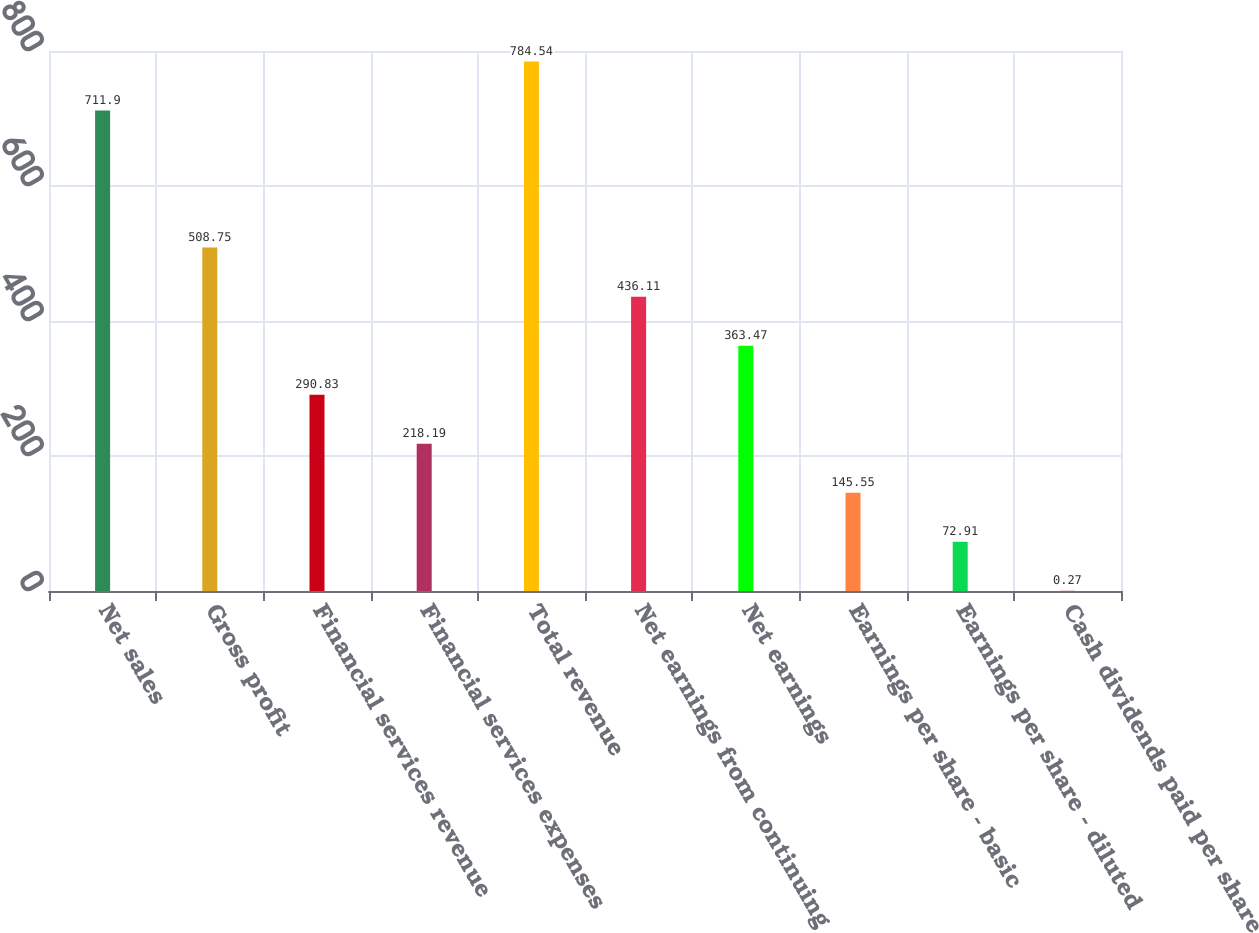Convert chart. <chart><loc_0><loc_0><loc_500><loc_500><bar_chart><fcel>Net sales<fcel>Gross profit<fcel>Financial services revenue<fcel>Financial services expenses<fcel>Total revenue<fcel>Net earnings from continuing<fcel>Net earnings<fcel>Earnings per share - basic<fcel>Earnings per share - diluted<fcel>Cash dividends paid per share<nl><fcel>711.9<fcel>508.75<fcel>290.83<fcel>218.19<fcel>784.54<fcel>436.11<fcel>363.47<fcel>145.55<fcel>72.91<fcel>0.27<nl></chart> 